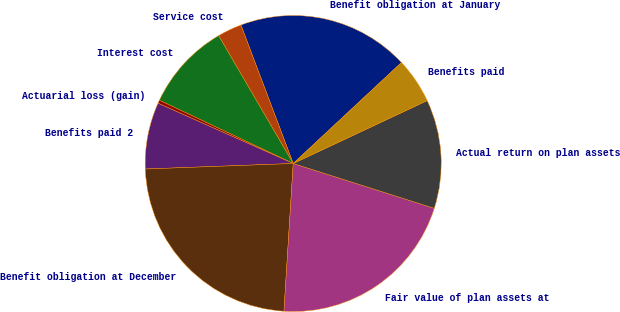Convert chart. <chart><loc_0><loc_0><loc_500><loc_500><pie_chart><fcel>Benefit obligation at January<fcel>Service cost<fcel>Interest cost<fcel>Actuarial loss (gain)<fcel>Benefits paid 2<fcel>Benefit obligation at December<fcel>Fair value of plan assets at<fcel>Actual return on plan assets<fcel>Benefits paid<nl><fcel>18.8%<fcel>2.66%<fcel>9.57%<fcel>0.35%<fcel>7.27%<fcel>23.41%<fcel>21.1%<fcel>11.88%<fcel>4.96%<nl></chart> 